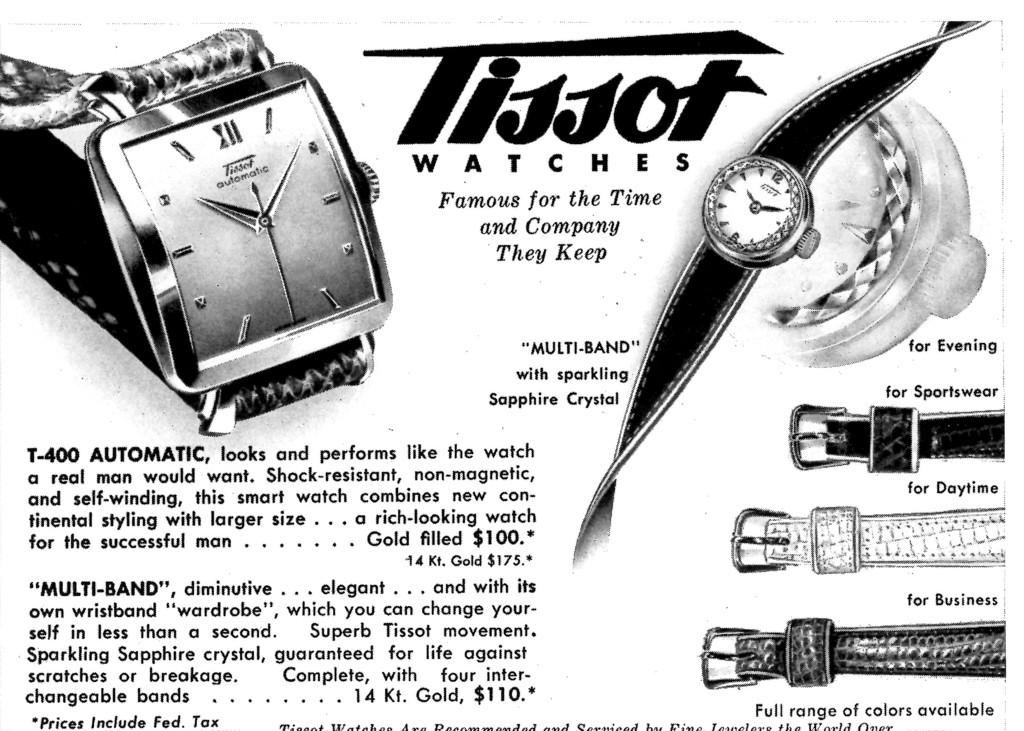<image>
Write a terse but informative summary of the picture. A Tissot watch ad says they come with a multi-band. 